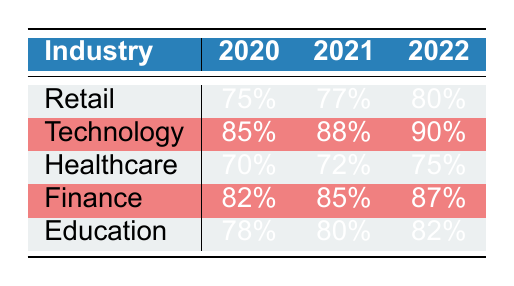What is the client retention rate for Retail in 2021? From the table, you can find the row for Retail and see the column for the year 2021, which shows a client retention rate of 77%.
Answer: 77% Which industry had the highest client retention rate in 2022? By examining the 2022 column, you can see that Technology has the highest retention rate at 90%, compared to the other industries listed.
Answer: Technology What is the difference in client retention rates between Finance and Healthcare in 2020? Looking at the table, Finance had a retention rate of 82% and Healthcare had 70% in 2020. The difference is calculated as 82% - 70% = 12%.
Answer: 12% Is the client retention rate for Education greater than that for Healthcare in 2021? For Education in 2021, the rate is 80%, whereas for Healthcare, it's 72%. Since 80% is greater than 72%, the statement is true.
Answer: Yes What was the average client retention rate for all industries in 2022? To find the average, add the retention rates for all industries in 2022: (80 + 90 + 75 + 87 + 82) = 414. There are 5 data points, so the average is 414 / 5 = 82.8%.
Answer: 82.8% 